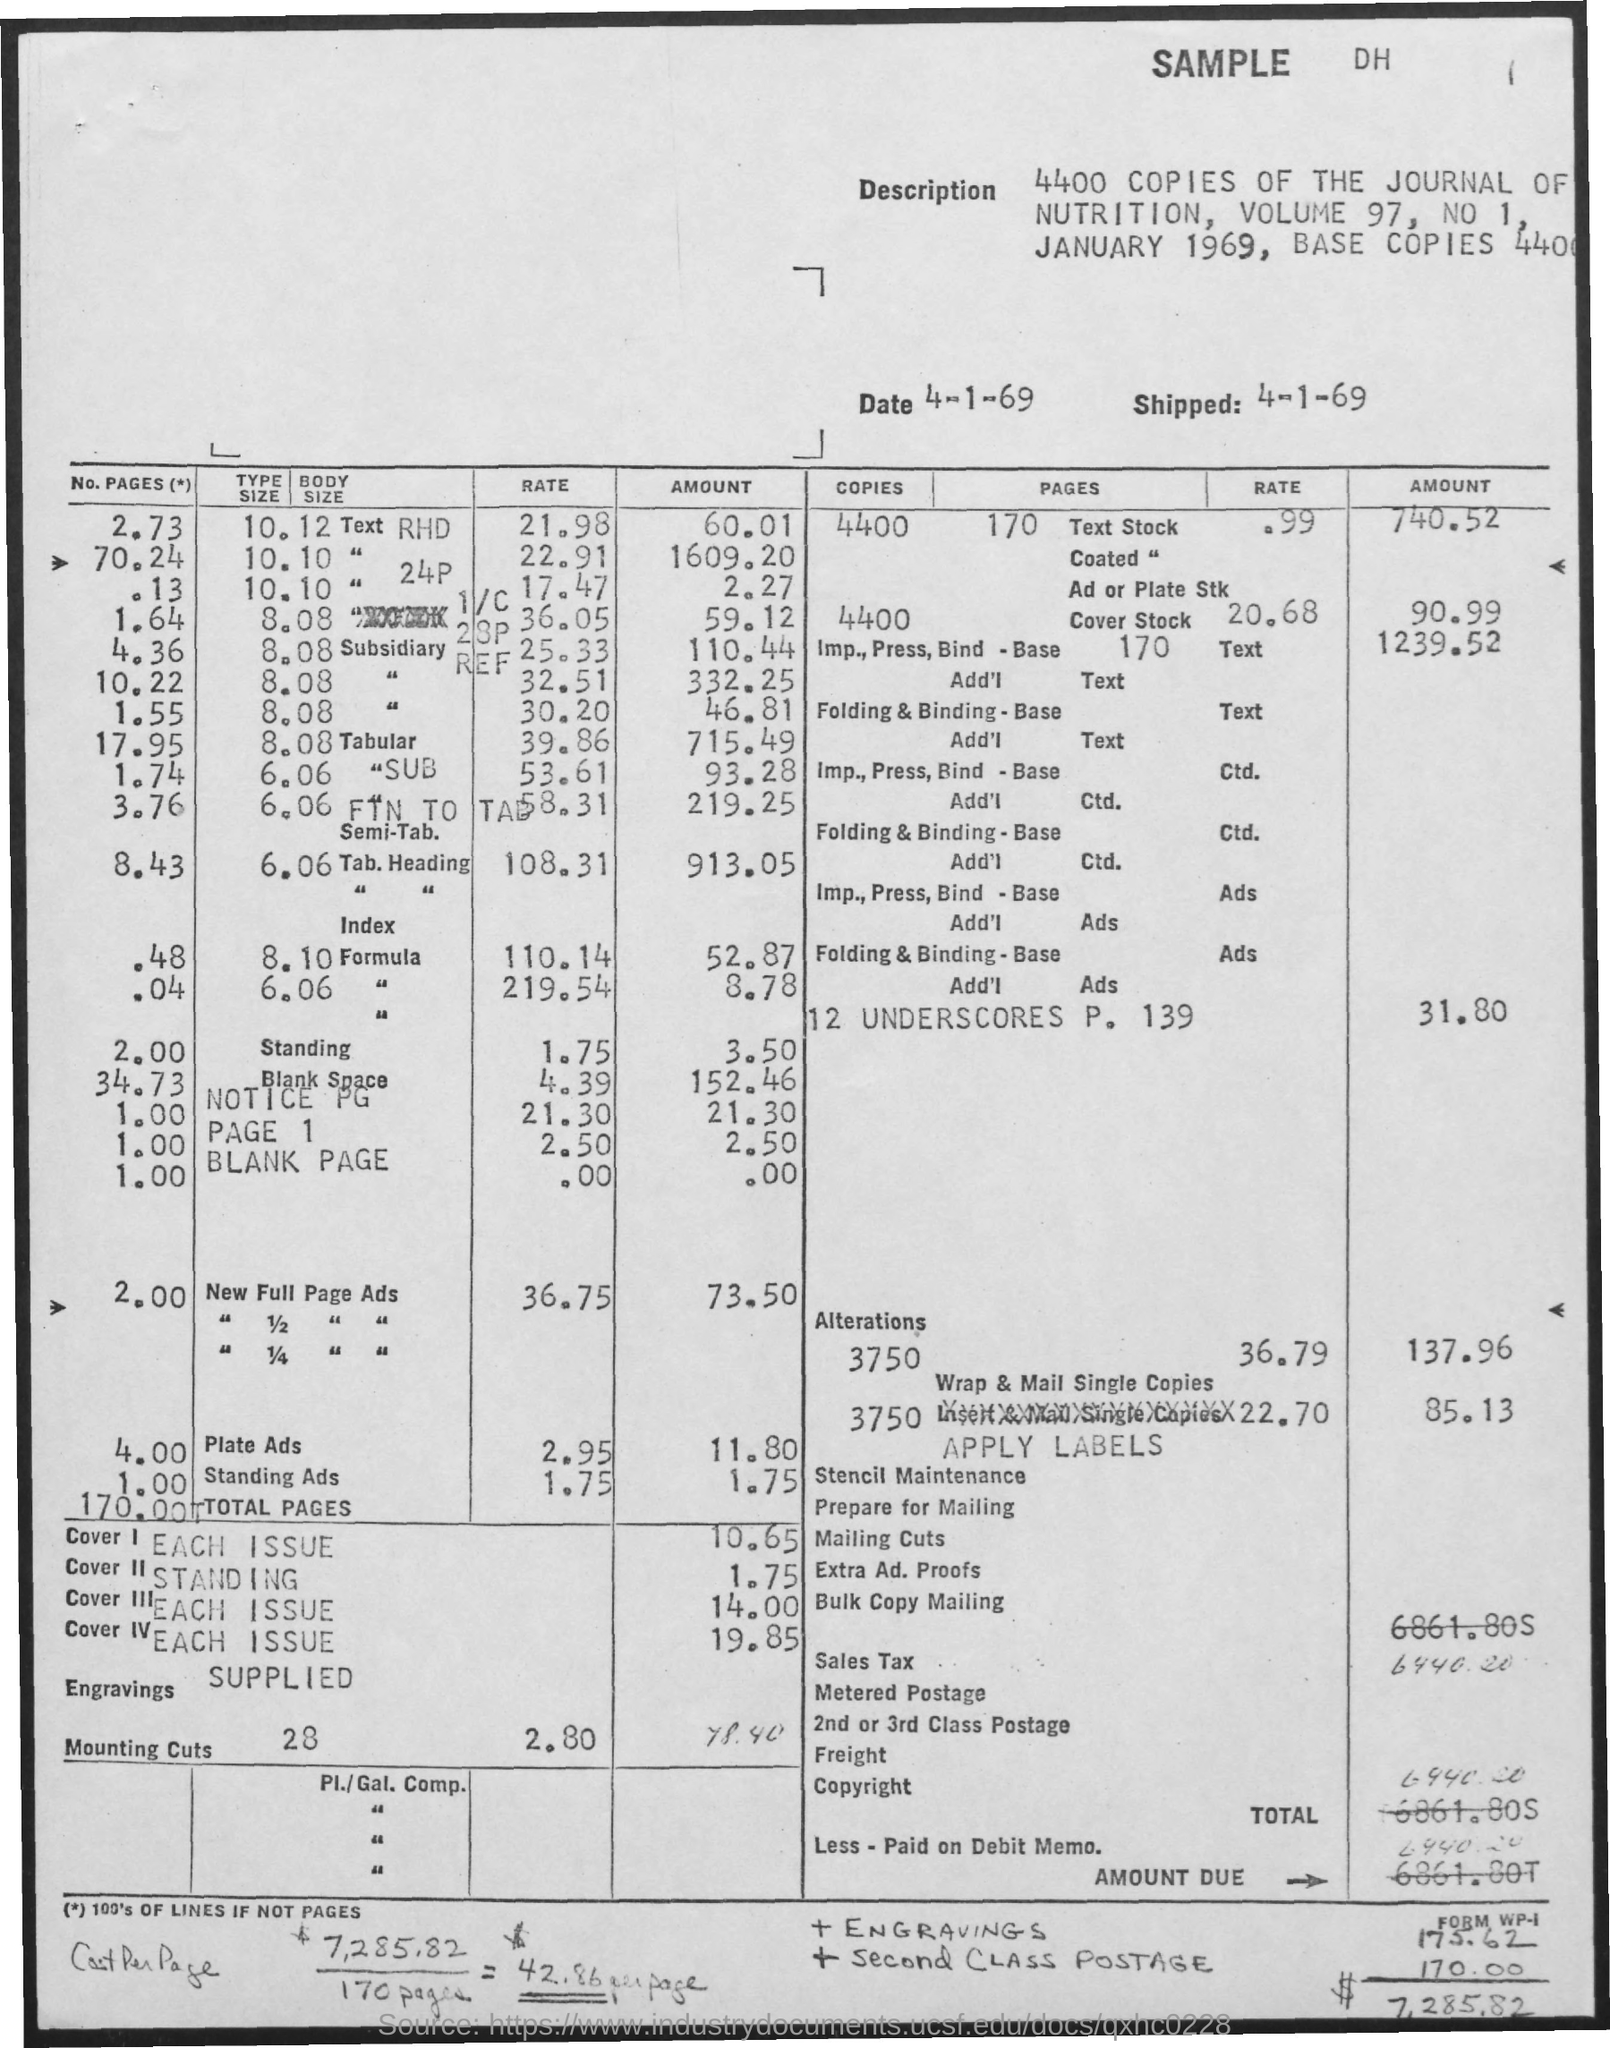Mention a couple of crucial points in this snapshot. The volume number is 97. The date of shipping is April 1, 1969. There are approximately 4,400 copies of the Journal of Nutrition in circulation. 